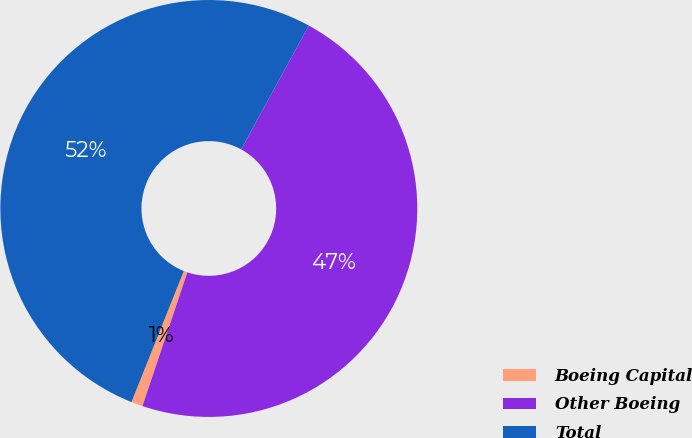Convert chart to OTSL. <chart><loc_0><loc_0><loc_500><loc_500><pie_chart><fcel>Boeing Capital<fcel>Other Boeing<fcel>Total<nl><fcel>0.89%<fcel>47.19%<fcel>51.91%<nl></chart> 